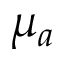<formula> <loc_0><loc_0><loc_500><loc_500>\mu _ { a }</formula> 